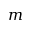<formula> <loc_0><loc_0><loc_500><loc_500>m</formula> 